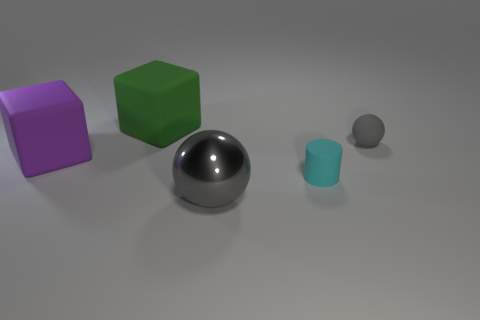How do the shadows in the image inform us about the light source? The alignment and length of shadows cast by the objects suggest that the light source is positioned above and to the left of the scene. The shadows help indicate the shape and the three-dimensional nature of the objects, as well as providing clues about their spatial relationship to one another. 